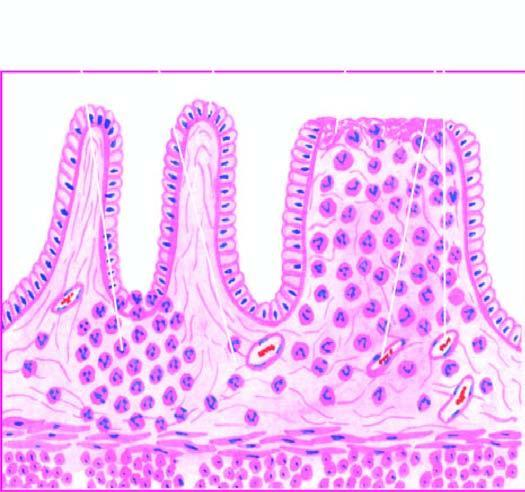re the microscopic features seen superficial ulcerations, with mucosal infiltration by inflammatory cells and a 'crypt abscess '?
Answer the question using a single word or phrase. Yes 